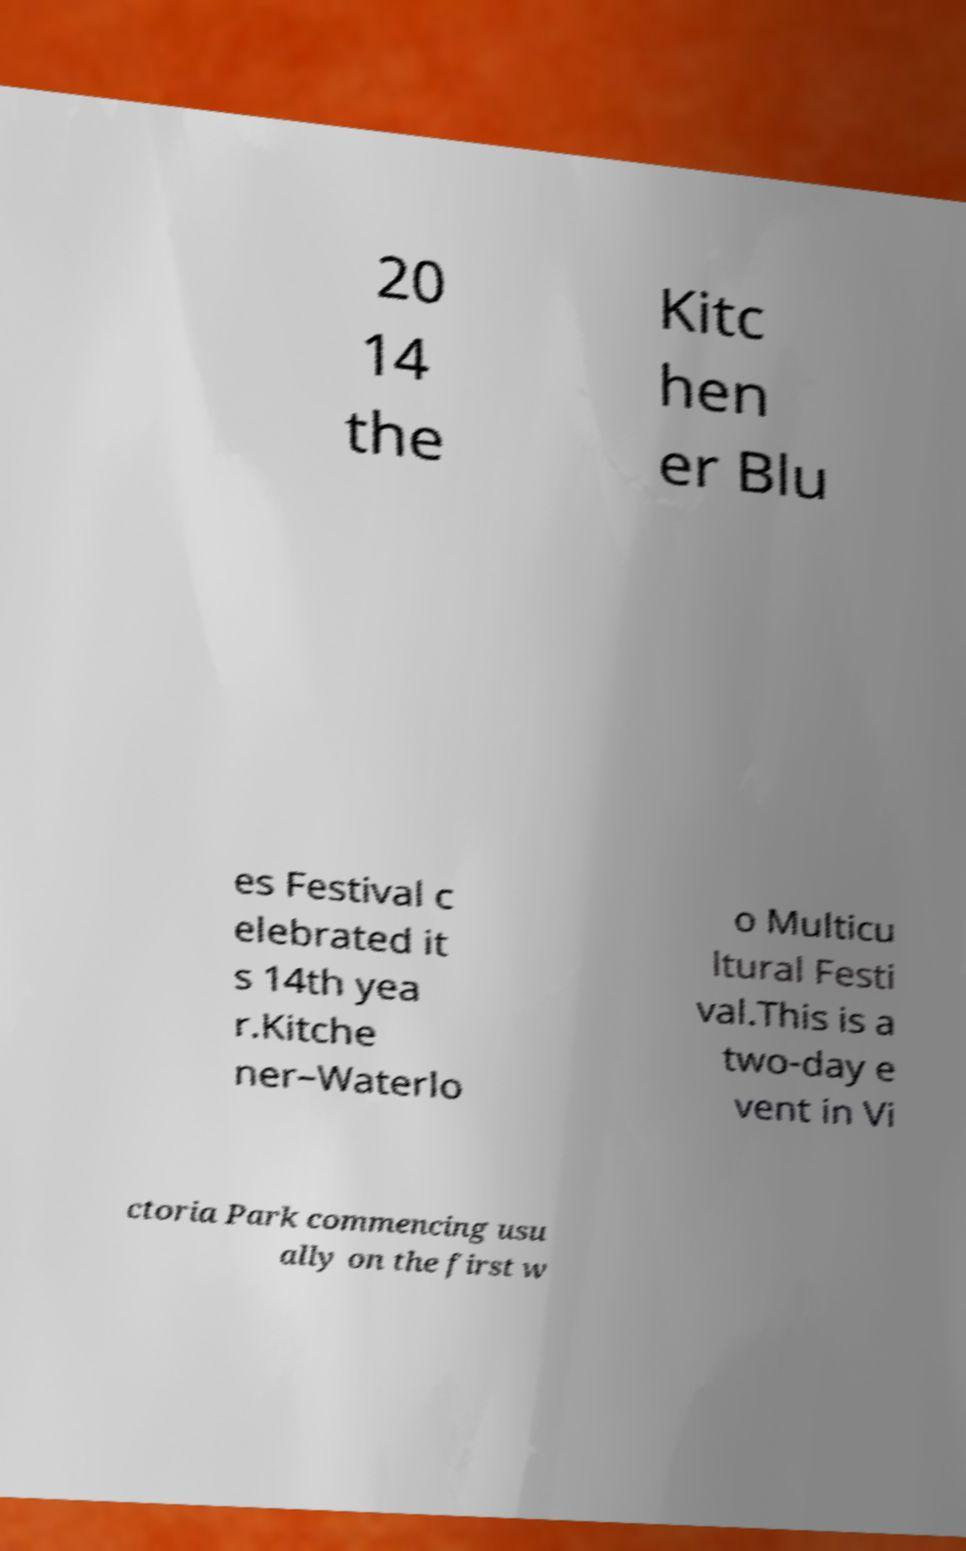There's text embedded in this image that I need extracted. Can you transcribe it verbatim? 20 14 the Kitc hen er Blu es Festival c elebrated it s 14th yea r.Kitche ner–Waterlo o Multicu ltural Festi val.This is a two-day e vent in Vi ctoria Park commencing usu ally on the first w 